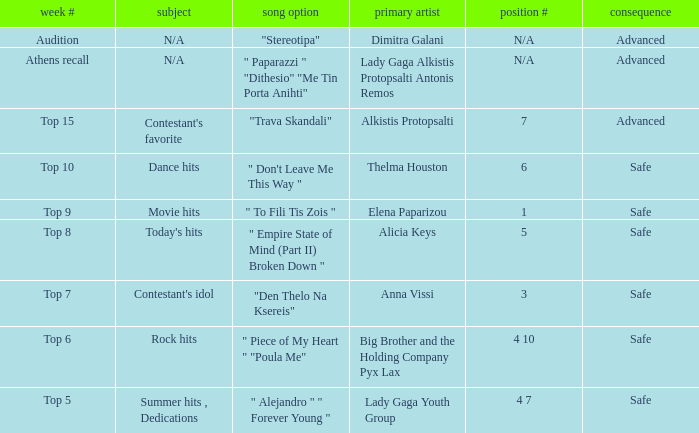Which week had the song choice " empire state of mind (part ii) broken down "? Top 8. 